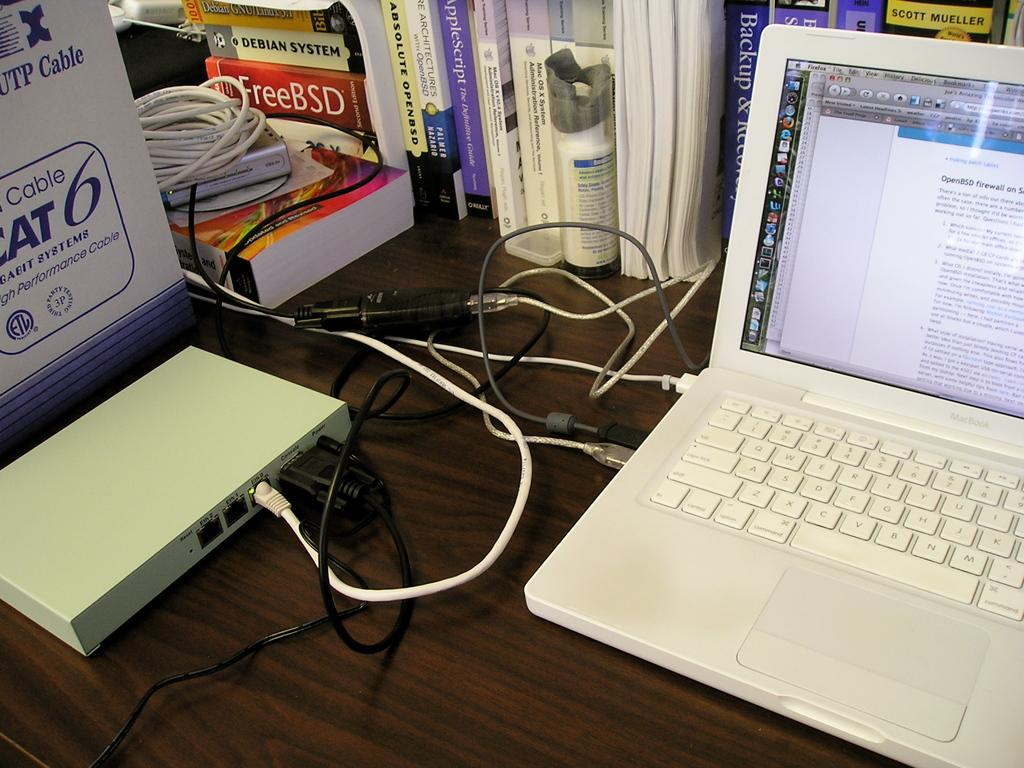<image>
Provide a brief description of the given image. A white laptop plugged in to a moden with the CAT cable box in the background. 